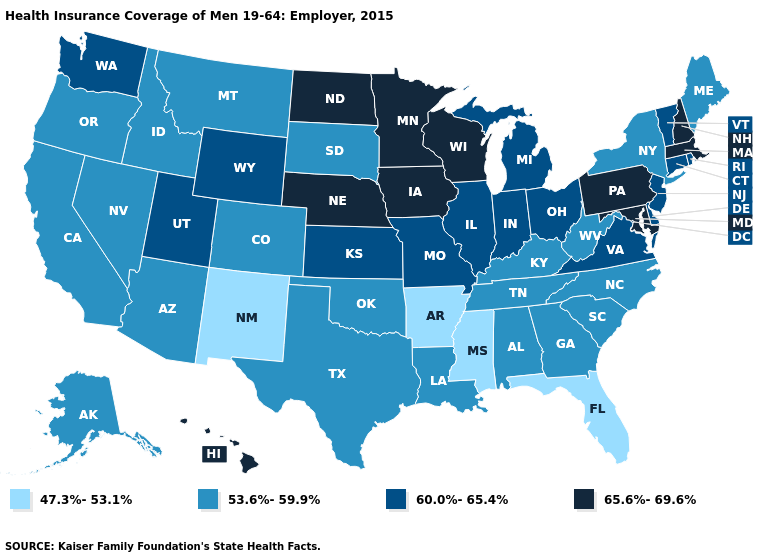Name the states that have a value in the range 60.0%-65.4%?
Be succinct. Connecticut, Delaware, Illinois, Indiana, Kansas, Michigan, Missouri, New Jersey, Ohio, Rhode Island, Utah, Vermont, Virginia, Washington, Wyoming. Does Nebraska have the highest value in the USA?
Write a very short answer. Yes. Name the states that have a value in the range 65.6%-69.6%?
Answer briefly. Hawaii, Iowa, Maryland, Massachusetts, Minnesota, Nebraska, New Hampshire, North Dakota, Pennsylvania, Wisconsin. Name the states that have a value in the range 47.3%-53.1%?
Write a very short answer. Arkansas, Florida, Mississippi, New Mexico. Is the legend a continuous bar?
Concise answer only. No. What is the value of Massachusetts?
Short answer required. 65.6%-69.6%. Which states hav the highest value in the MidWest?
Concise answer only. Iowa, Minnesota, Nebraska, North Dakota, Wisconsin. Name the states that have a value in the range 53.6%-59.9%?
Write a very short answer. Alabama, Alaska, Arizona, California, Colorado, Georgia, Idaho, Kentucky, Louisiana, Maine, Montana, Nevada, New York, North Carolina, Oklahoma, Oregon, South Carolina, South Dakota, Tennessee, Texas, West Virginia. How many symbols are there in the legend?
Write a very short answer. 4. Name the states that have a value in the range 47.3%-53.1%?
Write a very short answer. Arkansas, Florida, Mississippi, New Mexico. Among the states that border Wyoming , does Montana have the lowest value?
Answer briefly. Yes. Name the states that have a value in the range 47.3%-53.1%?
Quick response, please. Arkansas, Florida, Mississippi, New Mexico. Does the map have missing data?
Concise answer only. No. What is the lowest value in the USA?
Give a very brief answer. 47.3%-53.1%. Name the states that have a value in the range 60.0%-65.4%?
Give a very brief answer. Connecticut, Delaware, Illinois, Indiana, Kansas, Michigan, Missouri, New Jersey, Ohio, Rhode Island, Utah, Vermont, Virginia, Washington, Wyoming. 